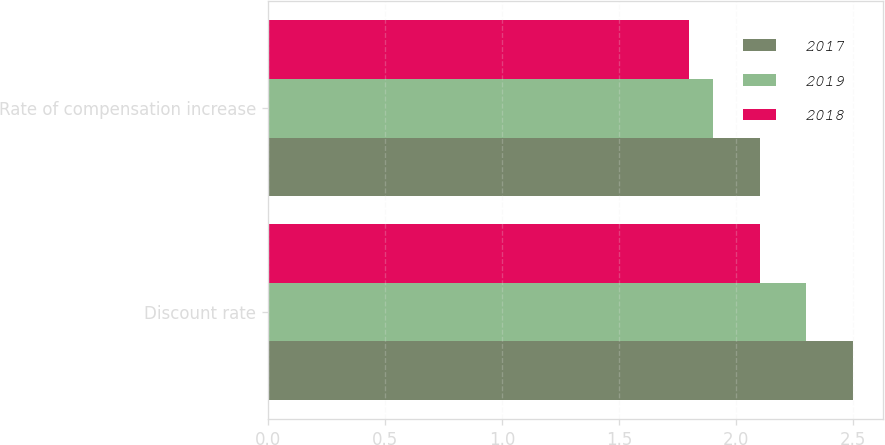<chart> <loc_0><loc_0><loc_500><loc_500><stacked_bar_chart><ecel><fcel>Discount rate<fcel>Rate of compensation increase<nl><fcel>2017<fcel>2.5<fcel>2.1<nl><fcel>2019<fcel>2.3<fcel>1.9<nl><fcel>2018<fcel>2.1<fcel>1.8<nl></chart> 